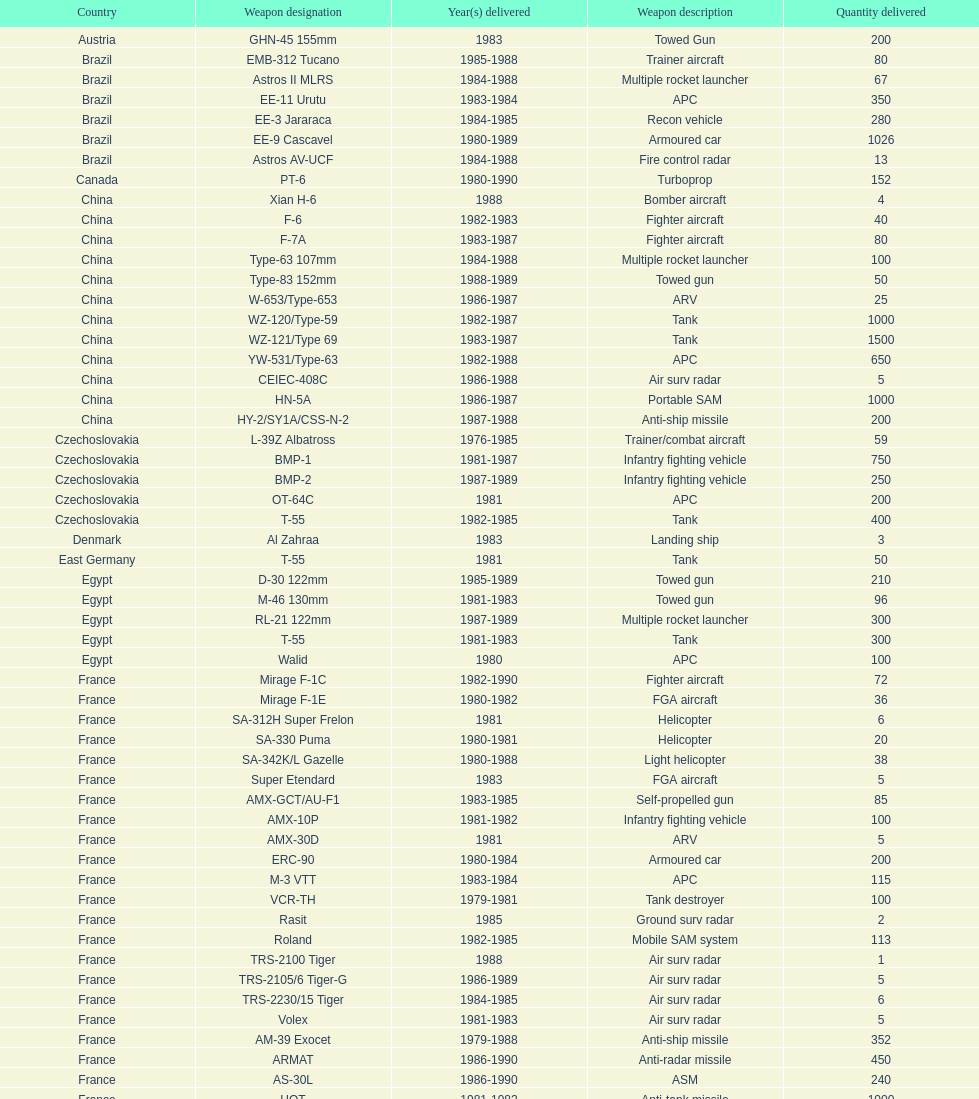Which was the first country to sell weapons to iraq? Czechoslovakia. 